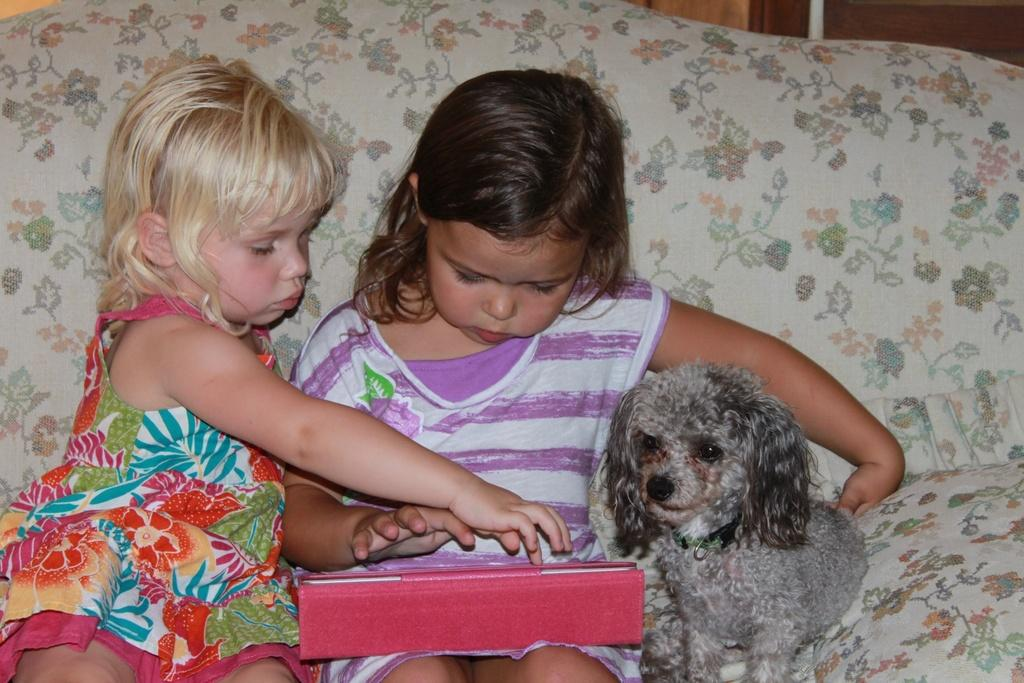How many people are in the image? There are two girls in the image. What other living creature is present in the image? There is a dog in the image. What are the girls and the dog doing in the image? The girls and the dog are sitting. What type of veil is the dog wearing in the image? There is no veil present in the image, and the dog is not wearing any clothing or accessories. 